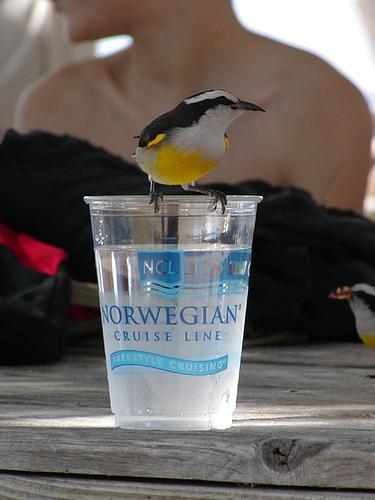How many cups are there?
Give a very brief answer. 1. 